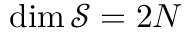<formula> <loc_0><loc_0><loc_500><loc_500>\dim { \mathcal { S } } = 2 N</formula> 